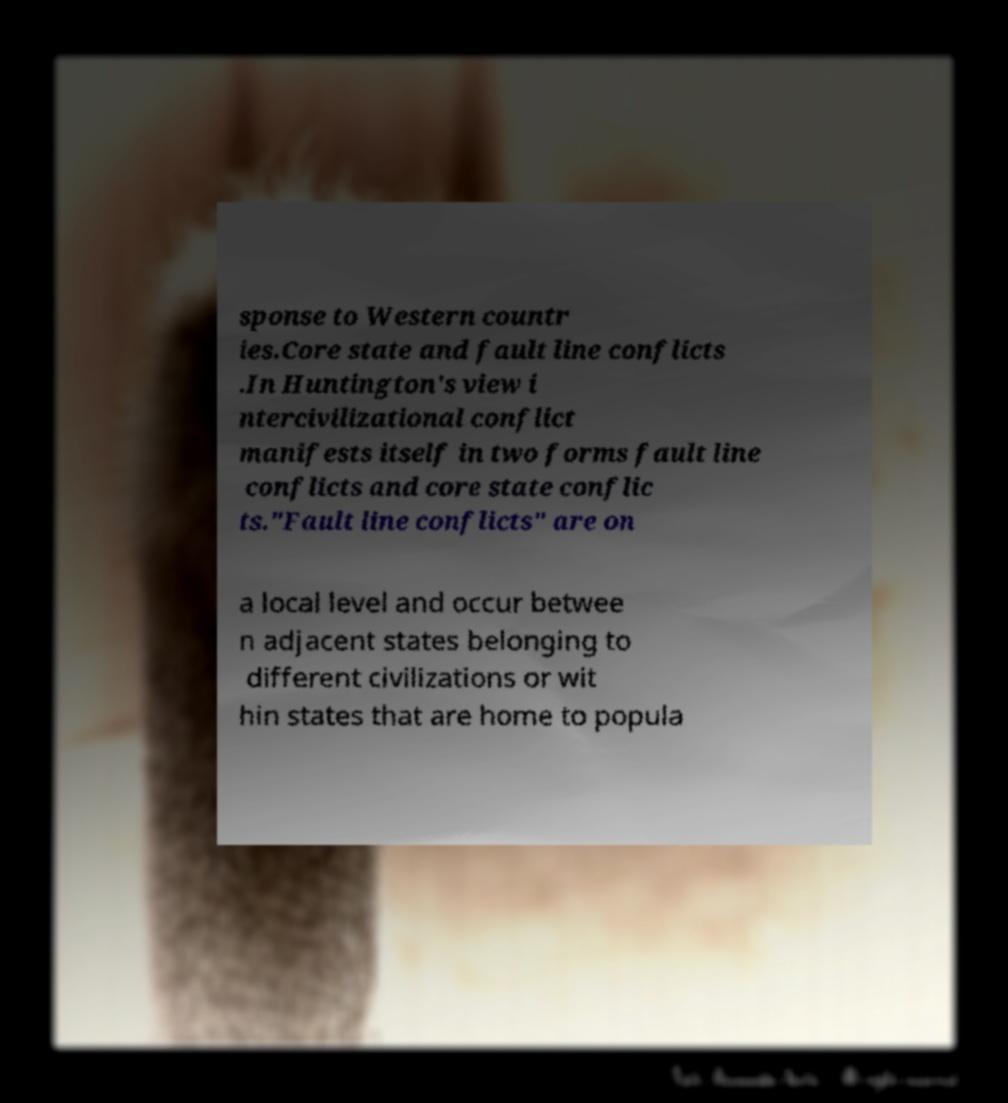Could you assist in decoding the text presented in this image and type it out clearly? sponse to Western countr ies.Core state and fault line conflicts .In Huntington's view i ntercivilizational conflict manifests itself in two forms fault line conflicts and core state conflic ts."Fault line conflicts" are on a local level and occur betwee n adjacent states belonging to different civilizations or wit hin states that are home to popula 